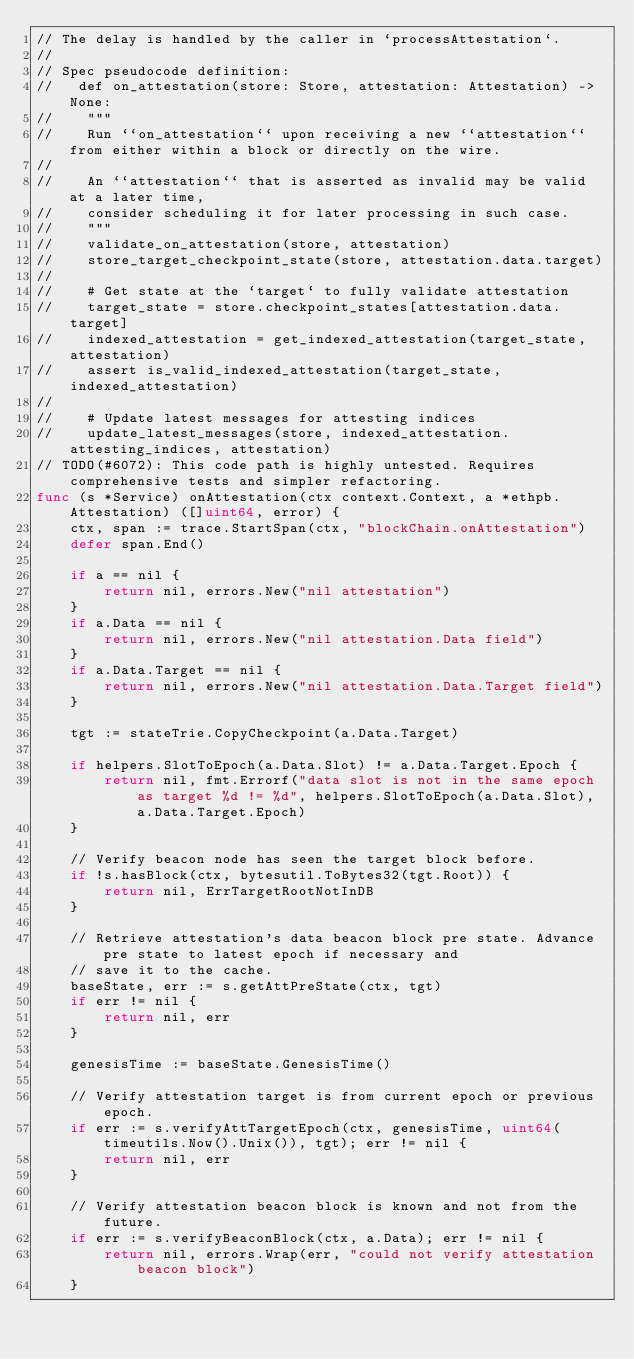<code> <loc_0><loc_0><loc_500><loc_500><_Go_>// The delay is handled by the caller in `processAttestation`.
//
// Spec pseudocode definition:
//   def on_attestation(store: Store, attestation: Attestation) -> None:
//    """
//    Run ``on_attestation`` upon receiving a new ``attestation`` from either within a block or directly on the wire.
//
//    An ``attestation`` that is asserted as invalid may be valid at a later time,
//    consider scheduling it for later processing in such case.
//    """
//    validate_on_attestation(store, attestation)
//    store_target_checkpoint_state(store, attestation.data.target)
//
//    # Get state at the `target` to fully validate attestation
//    target_state = store.checkpoint_states[attestation.data.target]
//    indexed_attestation = get_indexed_attestation(target_state, attestation)
//    assert is_valid_indexed_attestation(target_state, indexed_attestation)
//
//    # Update latest messages for attesting indices
//    update_latest_messages(store, indexed_attestation.attesting_indices, attestation)
// TODO(#6072): This code path is highly untested. Requires comprehensive tests and simpler refactoring.
func (s *Service) onAttestation(ctx context.Context, a *ethpb.Attestation) ([]uint64, error) {
	ctx, span := trace.StartSpan(ctx, "blockChain.onAttestation")
	defer span.End()

	if a == nil {
		return nil, errors.New("nil attestation")
	}
	if a.Data == nil {
		return nil, errors.New("nil attestation.Data field")
	}
	if a.Data.Target == nil {
		return nil, errors.New("nil attestation.Data.Target field")
	}

	tgt := stateTrie.CopyCheckpoint(a.Data.Target)

	if helpers.SlotToEpoch(a.Data.Slot) != a.Data.Target.Epoch {
		return nil, fmt.Errorf("data slot is not in the same epoch as target %d != %d", helpers.SlotToEpoch(a.Data.Slot), a.Data.Target.Epoch)
	}

	// Verify beacon node has seen the target block before.
	if !s.hasBlock(ctx, bytesutil.ToBytes32(tgt.Root)) {
		return nil, ErrTargetRootNotInDB
	}

	// Retrieve attestation's data beacon block pre state. Advance pre state to latest epoch if necessary and
	// save it to the cache.
	baseState, err := s.getAttPreState(ctx, tgt)
	if err != nil {
		return nil, err
	}

	genesisTime := baseState.GenesisTime()

	// Verify attestation target is from current epoch or previous epoch.
	if err := s.verifyAttTargetEpoch(ctx, genesisTime, uint64(timeutils.Now().Unix()), tgt); err != nil {
		return nil, err
	}

	// Verify attestation beacon block is known and not from the future.
	if err := s.verifyBeaconBlock(ctx, a.Data); err != nil {
		return nil, errors.Wrap(err, "could not verify attestation beacon block")
	}
</code> 